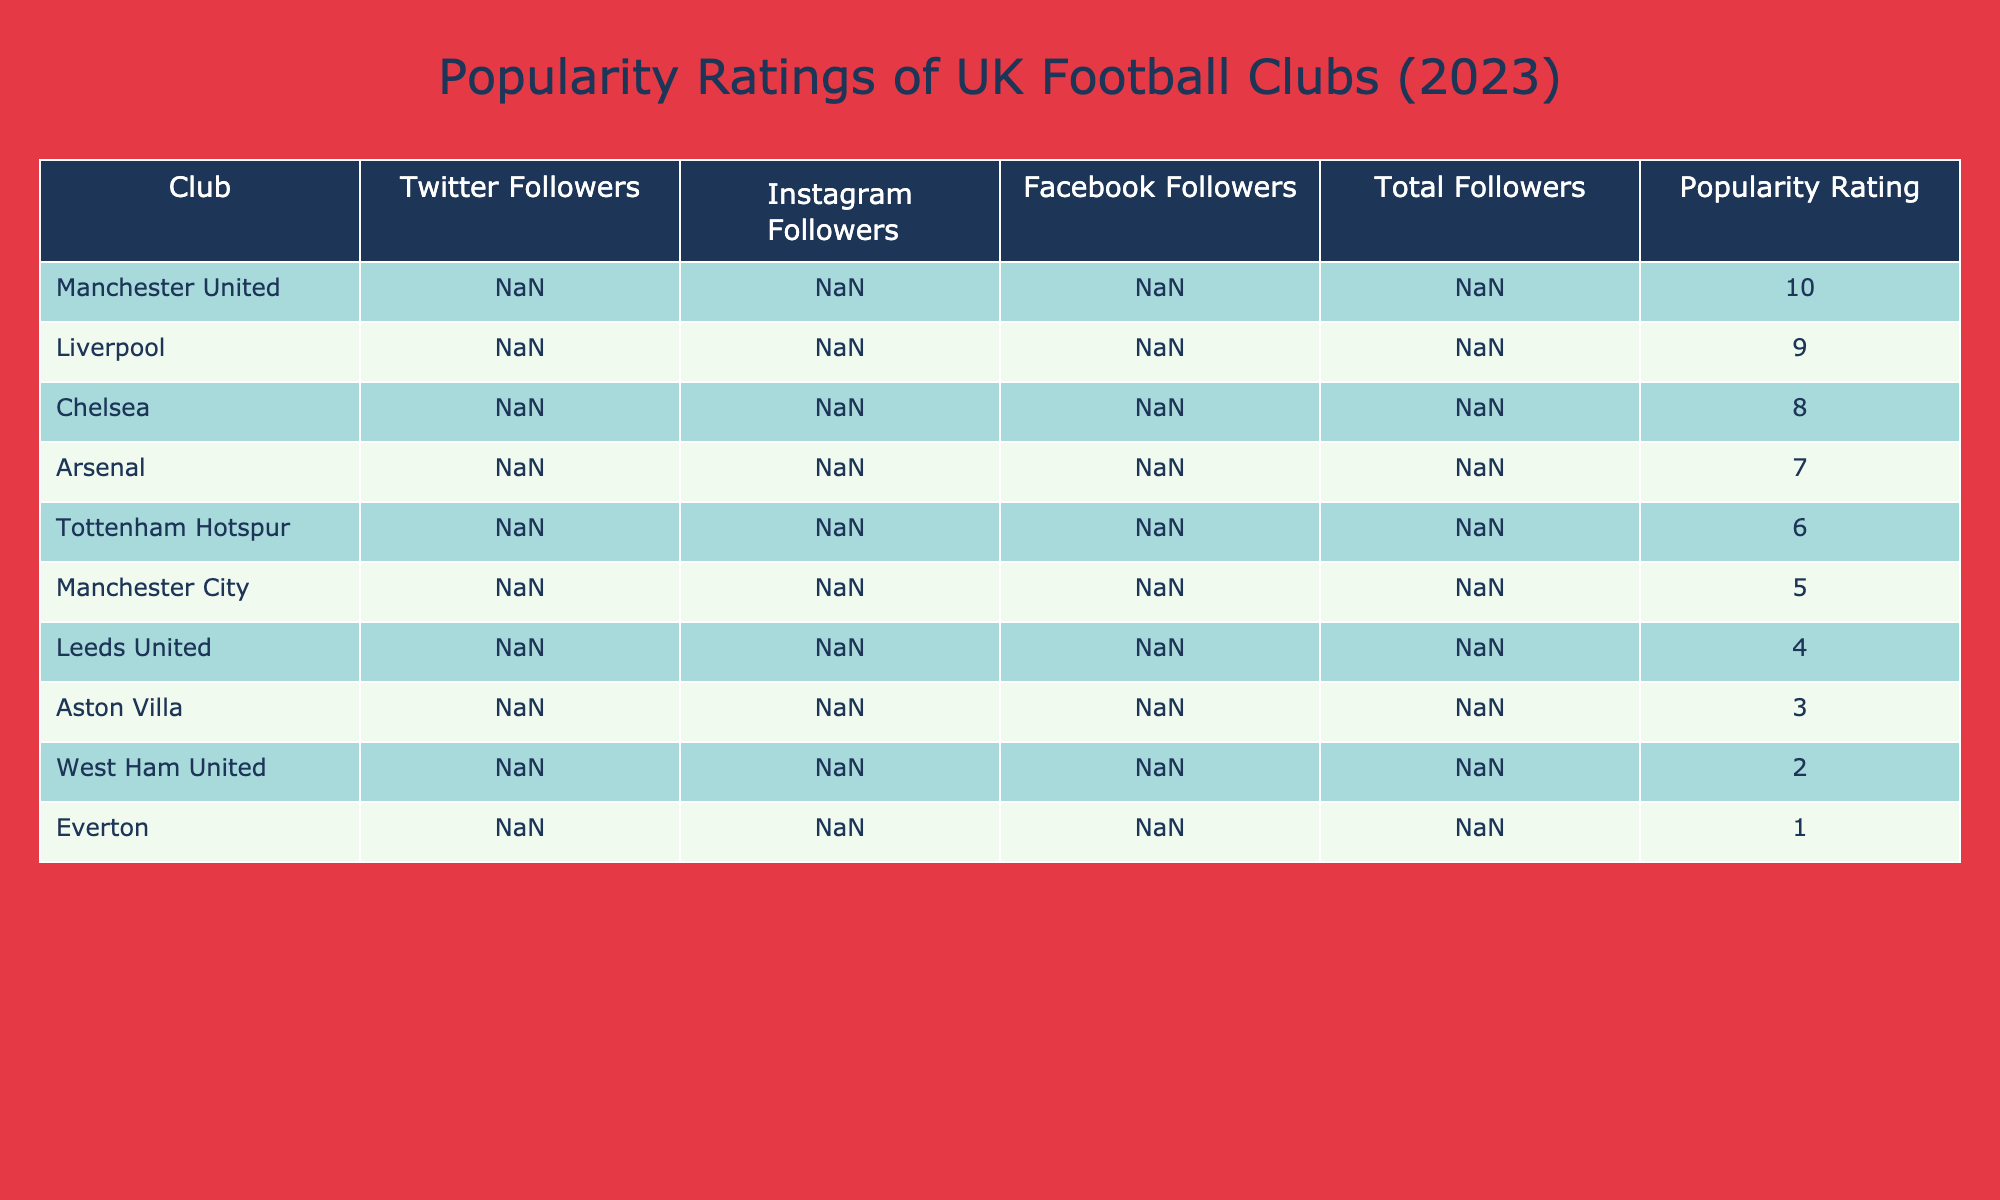What is the total number of followers for Arsenal? Looking at the "Total Followers" column in the table, Arsenal has a total of 85.5 million followers.
Answer: 85.5M Which club has the highest number of Twitter followers? By checking the "Twitter Followers" column, Manchester United has the most followers with 36.5 million.
Answer: 36.5M What is the popularity rating for Leeds United? According to the table, Leeds United has a popularity rating of 4.
Answer: 4 How many more total followers does Liverpool have than Tottenham Hotspur? Liverpool has 117.9 million followers and Tottenham Hotspur has 62.6 million. The difference is 117.9M - 62.6M = 55.3M.
Answer: 55.3M Is Chelsea's popularity rating higher than that of Arsenal? Chelsea has a popularity rating of 8 and Arsenal has a rating of 7. Since 8 is higher than 7, yes, Chelsea's rating is higher.
Answer: Yes What is the average number of Instagram followers across all clubs listed? To find the average, add all the Instagram followers: (32.1 + 33.2 + 31 + 22.1 + 12.4 + 10.8 + 6.5 + 5.7 + 4.0 + 3.1) million =  24.0 million. Divide this sum by the number of clubs (10):  24.0M / 10 = 2.4M.
Answer: 2.4M How many clubs have a popularity rating of 6 or lower? The clubs with a popularity rating of 6 or lower are Tottenham Hotspur, Manchester City, Leeds United, Aston Villa, West Ham United, and Everton, totaling 6 clubs.
Answer: 6 What is the combined total followers for Manchester United and Liverpool? Manchester United has 142.6 million followers and Liverpool has 117.9 million. When added together, we get 142.6M + 117.9M = 260.5M.
Answer: 260.5M Which club has the least number of total followers? By inspecting the "Total Followers" column, Everton has the least followers with 16.9 million.
Answer: 16.9M How does the number of Facebook followers for Chelsea compare to that of Manchester City? Chelsea has 54 million Facebook followers while Manchester City has 20 million. Therefore, Chelsea has more Facebook followers than Manchester City.
Answer: Chelsea has more followers 